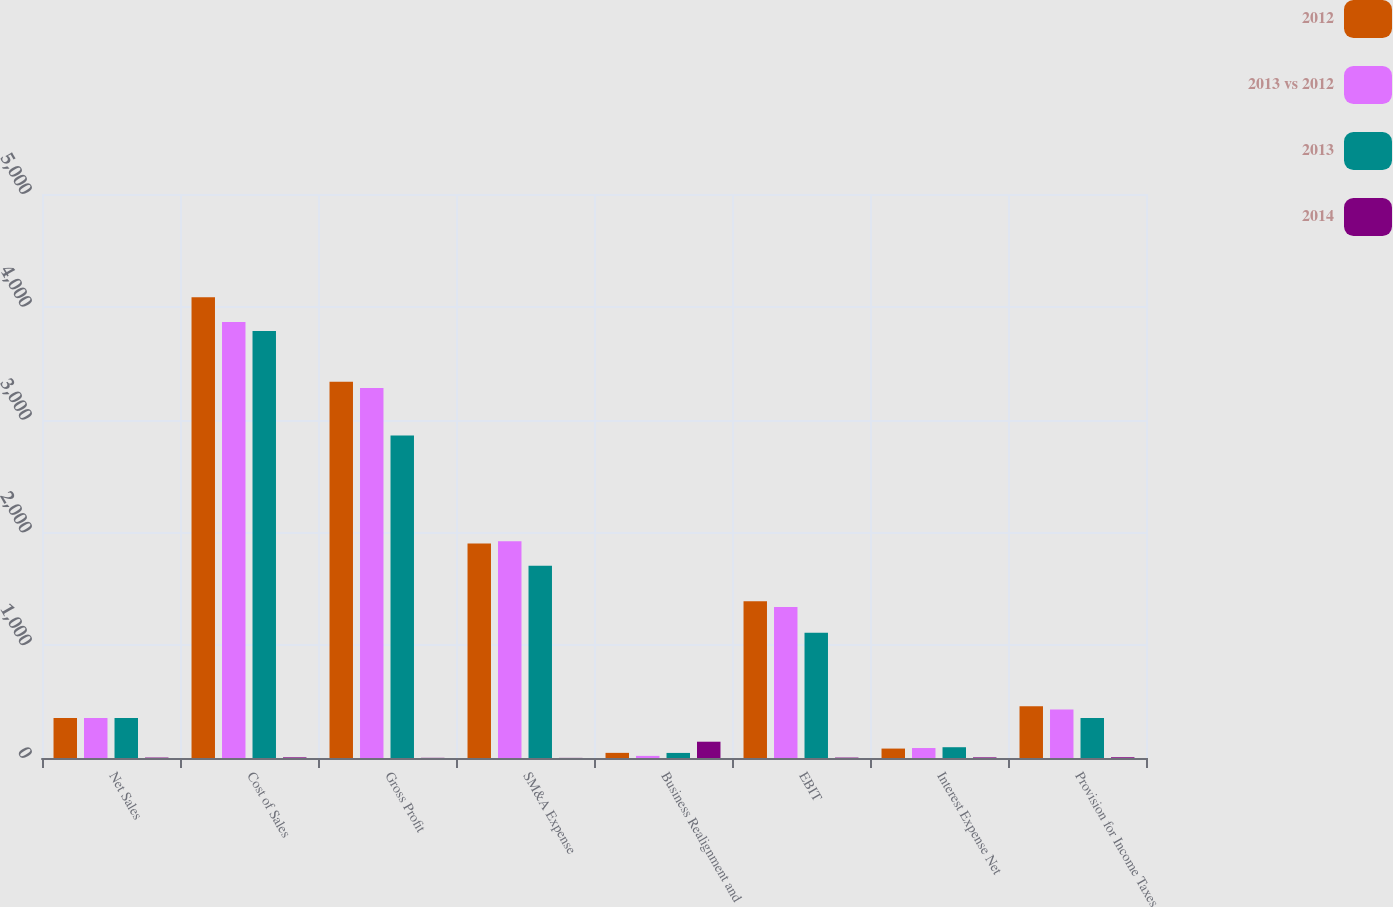<chart> <loc_0><loc_0><loc_500><loc_500><stacked_bar_chart><ecel><fcel>Net Sales<fcel>Cost of Sales<fcel>Gross Profit<fcel>SM&A Expense<fcel>Business Realignment and<fcel>EBIT<fcel>Interest Expense Net<fcel>Provision for Income Taxes<nl><fcel>2012<fcel>354.6<fcel>4085.6<fcel>3336.2<fcel>1901<fcel>45.6<fcel>1389.6<fcel>83.6<fcel>459.1<nl><fcel>2013 vs 2012<fcel>354.6<fcel>3865.2<fcel>3280.8<fcel>1922.5<fcel>18.6<fcel>1339.7<fcel>88.4<fcel>430.8<nl><fcel>2013<fcel>354.6<fcel>3784.4<fcel>2859.9<fcel>1703.8<fcel>45<fcel>1111.1<fcel>95.6<fcel>354.6<nl><fcel>2014<fcel>3.9<fcel>5.7<fcel>1.7<fcel>1.1<fcel>144.4<fcel>3.7<fcel>5.5<fcel>6.6<nl></chart> 